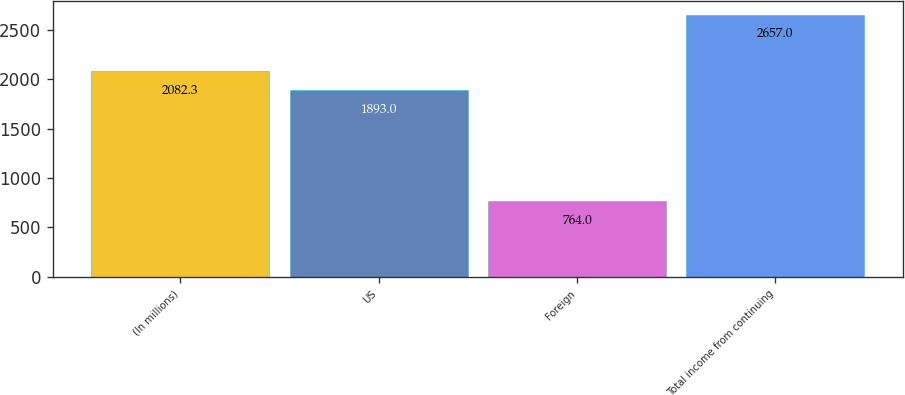<chart> <loc_0><loc_0><loc_500><loc_500><bar_chart><fcel>(In millions)<fcel>US<fcel>Foreign<fcel>Total income from continuing<nl><fcel>2082.3<fcel>1893<fcel>764<fcel>2657<nl></chart> 